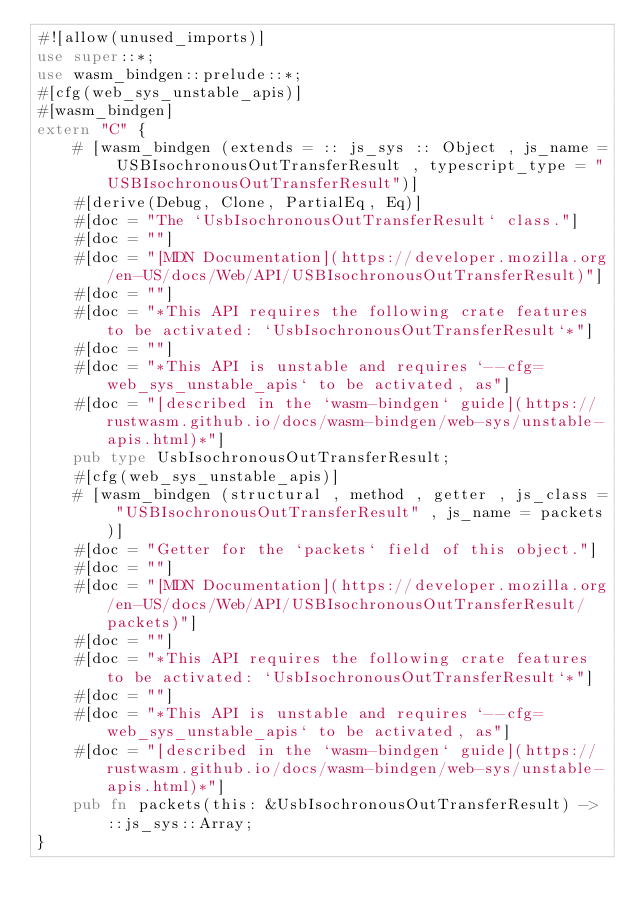<code> <loc_0><loc_0><loc_500><loc_500><_Rust_>#![allow(unused_imports)]
use super::*;
use wasm_bindgen::prelude::*;
#[cfg(web_sys_unstable_apis)]
#[wasm_bindgen]
extern "C" {
    # [wasm_bindgen (extends = :: js_sys :: Object , js_name = USBIsochronousOutTransferResult , typescript_type = "USBIsochronousOutTransferResult")]
    #[derive(Debug, Clone, PartialEq, Eq)]
    #[doc = "The `UsbIsochronousOutTransferResult` class."]
    #[doc = ""]
    #[doc = "[MDN Documentation](https://developer.mozilla.org/en-US/docs/Web/API/USBIsochronousOutTransferResult)"]
    #[doc = ""]
    #[doc = "*This API requires the following crate features to be activated: `UsbIsochronousOutTransferResult`*"]
    #[doc = ""]
    #[doc = "*This API is unstable and requires `--cfg=web_sys_unstable_apis` to be activated, as"]
    #[doc = "[described in the `wasm-bindgen` guide](https://rustwasm.github.io/docs/wasm-bindgen/web-sys/unstable-apis.html)*"]
    pub type UsbIsochronousOutTransferResult;
    #[cfg(web_sys_unstable_apis)]
    # [wasm_bindgen (structural , method , getter , js_class = "USBIsochronousOutTransferResult" , js_name = packets)]
    #[doc = "Getter for the `packets` field of this object."]
    #[doc = ""]
    #[doc = "[MDN Documentation](https://developer.mozilla.org/en-US/docs/Web/API/USBIsochronousOutTransferResult/packets)"]
    #[doc = ""]
    #[doc = "*This API requires the following crate features to be activated: `UsbIsochronousOutTransferResult`*"]
    #[doc = ""]
    #[doc = "*This API is unstable and requires `--cfg=web_sys_unstable_apis` to be activated, as"]
    #[doc = "[described in the `wasm-bindgen` guide](https://rustwasm.github.io/docs/wasm-bindgen/web-sys/unstable-apis.html)*"]
    pub fn packets(this: &UsbIsochronousOutTransferResult) -> ::js_sys::Array;
}
</code> 